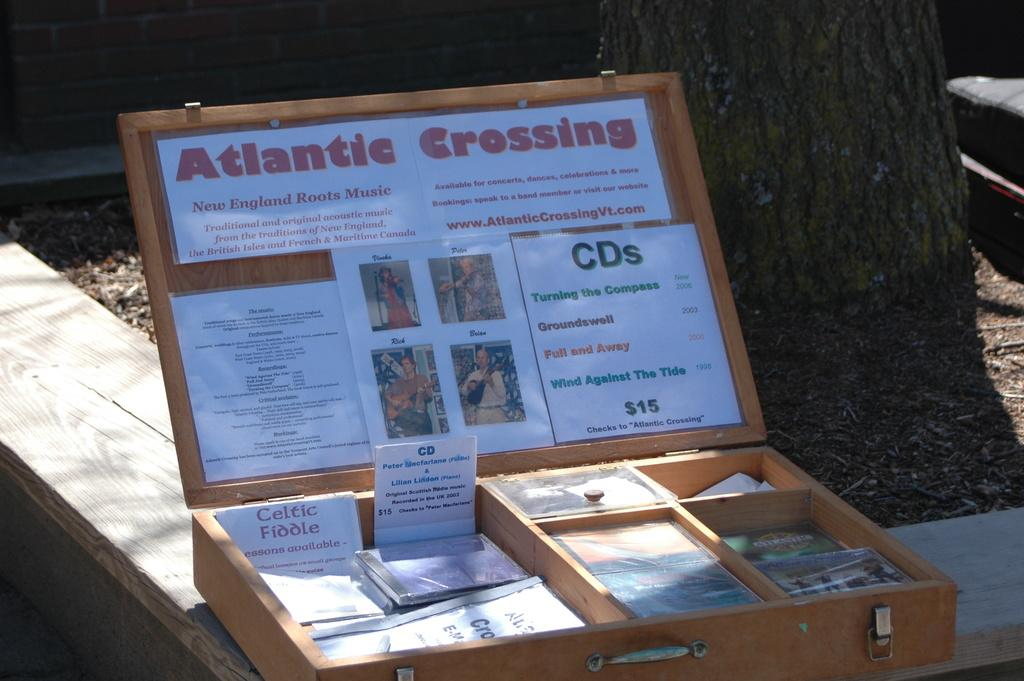<image>
Share a concise interpretation of the image provided. a box with a sign that says atlantic crossing on it and Cds for 15 dollars 